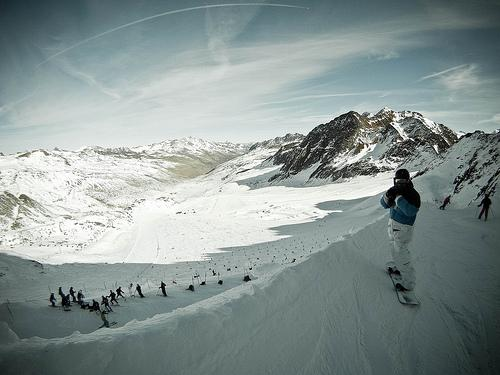Question: who is at the top of the hill?
Choices:
A. Skater.
B. The boy.
C. The hiker.
D. Snowboarder.
Answer with the letter. Answer: D Question: where was this picture taken?
Choices:
A. In the yard.
B. Near the fence.
C. On the lawn.
D. The mountains.
Answer with the letter. Answer: D Question: why are the people wearing coats?
Choices:
A. To try them on.
B. It's raining.
C. It's snowing.
D. It's cold outside.
Answer with the letter. Answer: D Question: how many snowboarders are on the top of the hill?
Choices:
A. Three.
B. Two.
C. One.
D. Zero.
Answer with the letter. Answer: C 